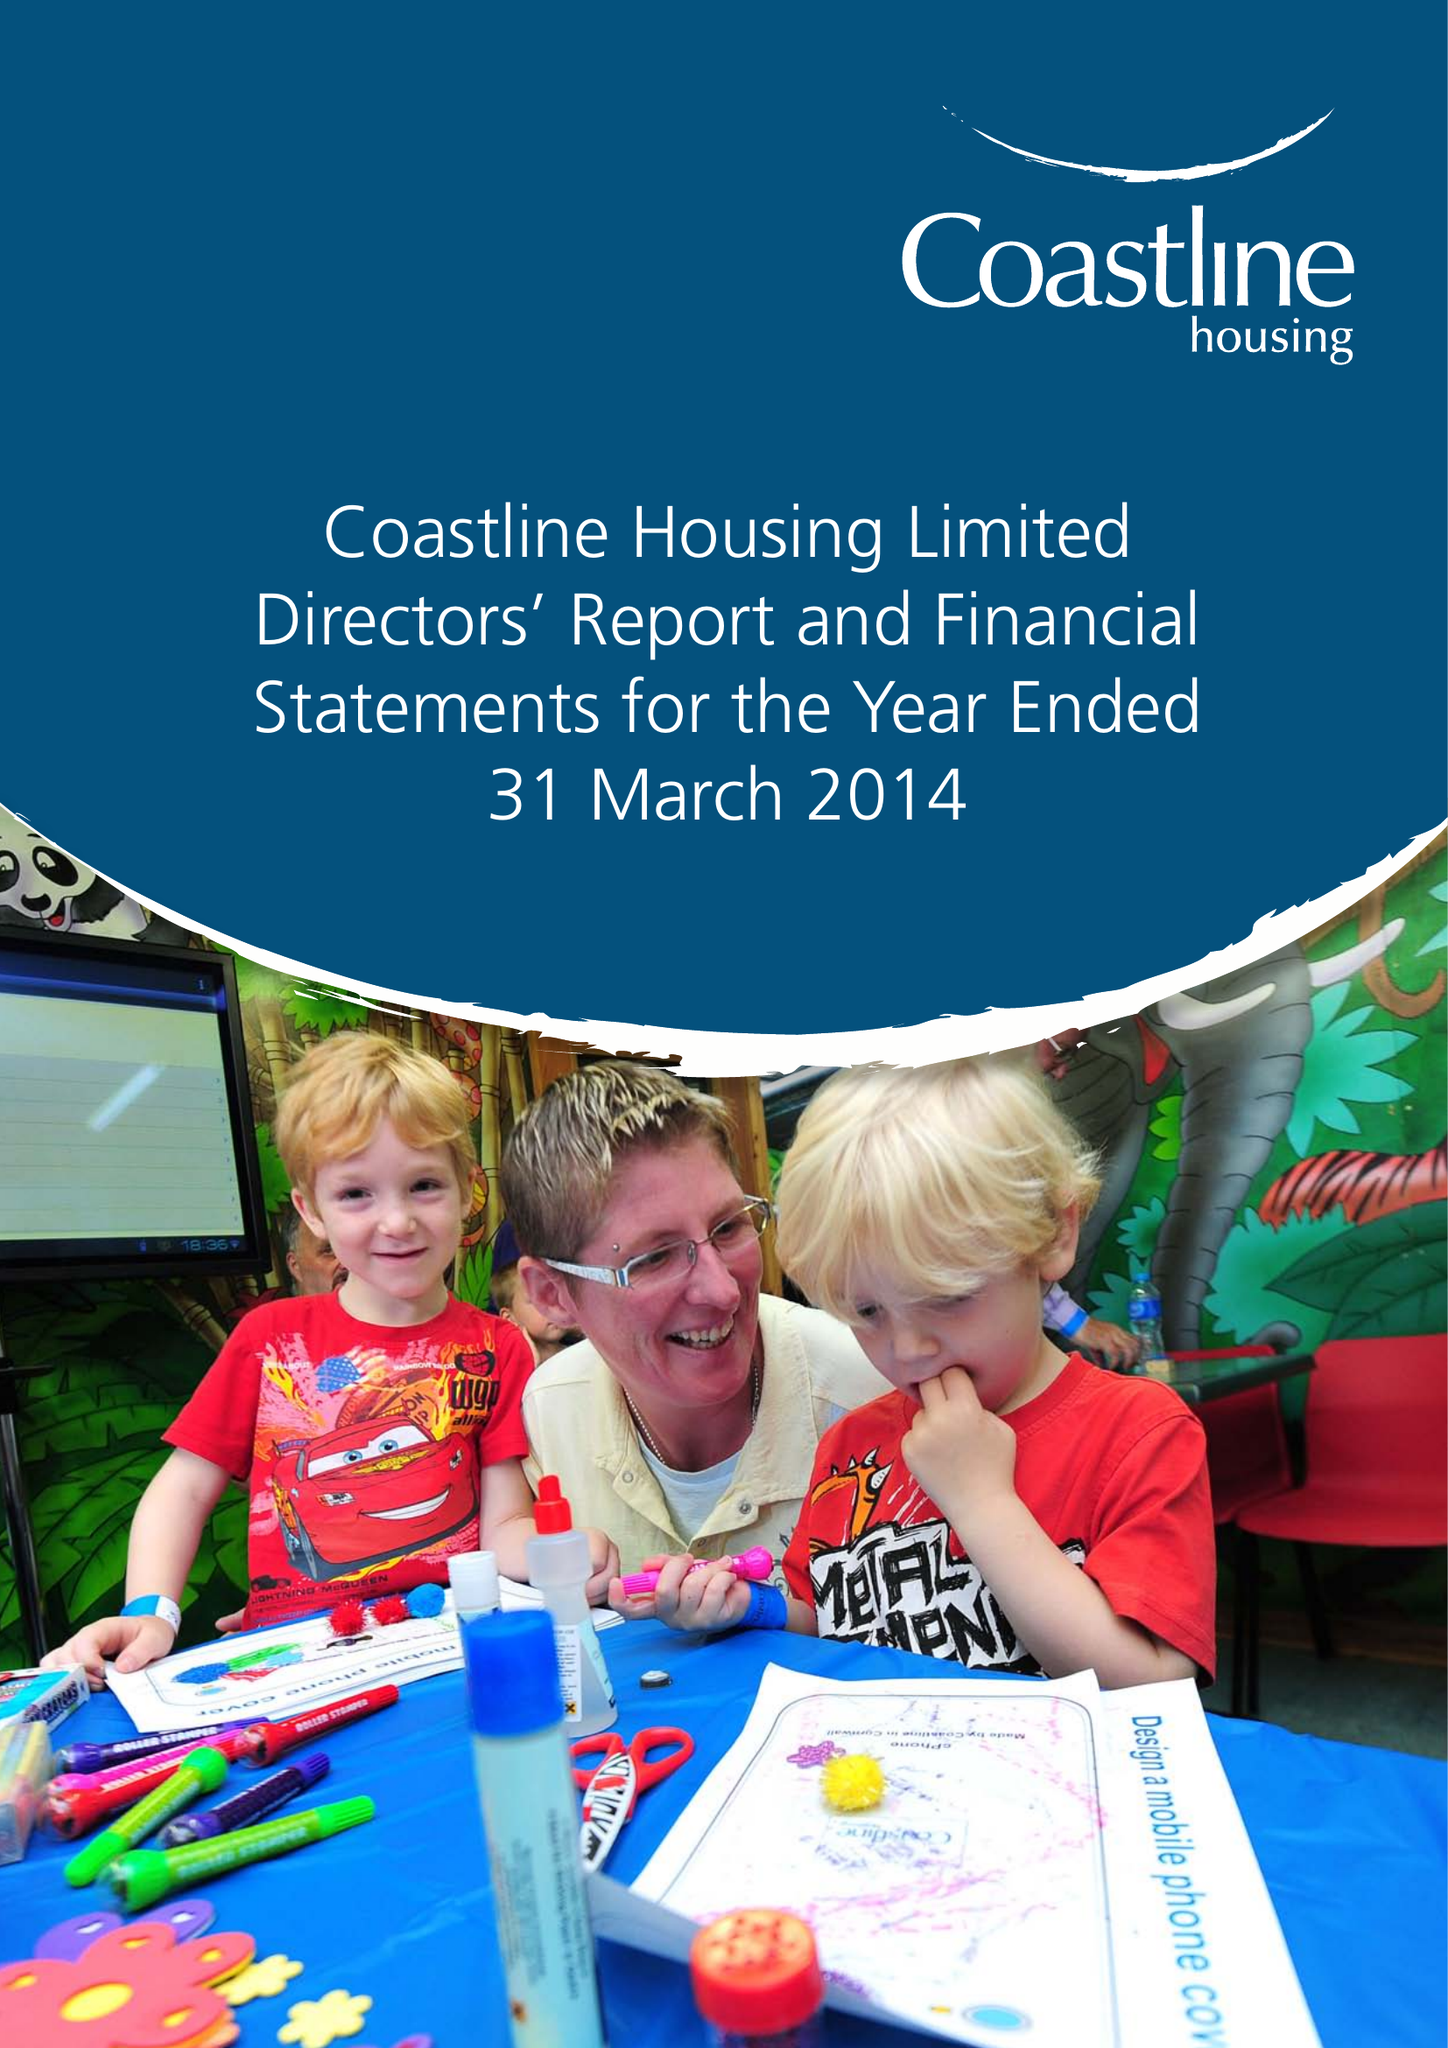What is the value for the charity_number?
Answer the question using a single word or phrase. 1066916 